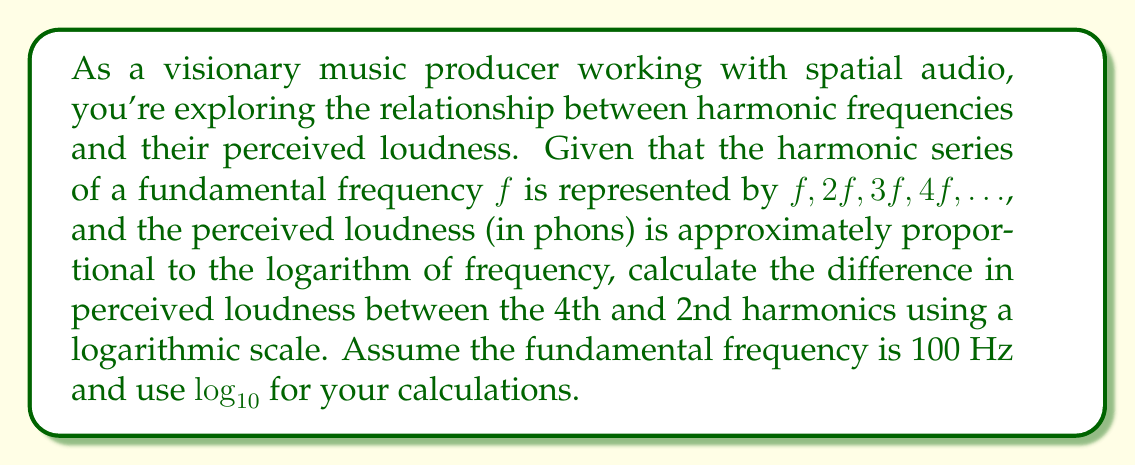What is the answer to this math problem? To solve this problem, we'll follow these steps:

1) First, let's identify the frequencies of the 2nd and 4th harmonics:
   2nd harmonic: $2f = 2 \cdot 100 \text{ Hz} = 200 \text{ Hz}$
   4th harmonic: $4f = 4 \cdot 100 \text{ Hz} = 400 \text{ Hz}$

2) The perceived loudness is proportional to the logarithm of frequency. Let's call this loudness L:
   $L \propto \log_{10}(f)$

3) To find the difference in perceived loudness, we need to calculate:
   $\Delta L = L_4 - L_2 = k\log_{10}(400) - k\log_{10}(200)$
   where k is some constant of proportionality.

4) Using the properties of logarithms, we can simplify:
   $\Delta L = k(\log_{10}(400) - \log_{10}(200))$
   $\Delta L = k\log_{10}(\frac{400}{200})$
   $\Delta L = k\log_{10}(2)$

5) The constant k will determine the actual units of loudness, but we're only interested in the relative difference. So we can consider k = 1 for simplicity.

6) Therefore, the difference in perceived loudness is:
   $\Delta L = \log_{10}(2) \approx 0.301$

This means that on a logarithmic scale, the 4th harmonic is perceived as about 0.301 units louder than the 2nd harmonic.
Answer: $\log_{10}(2) \approx 0.301$ 